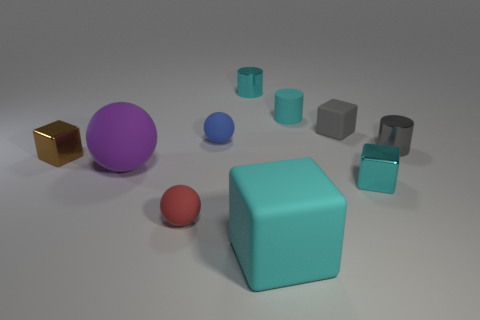Subtract all rubber cylinders. How many cylinders are left? 2 Subtract all red cubes. How many cyan cylinders are left? 2 Subtract 2 cubes. How many cubes are left? 2 Subtract all cubes. How many objects are left? 6 Subtract all brown blocks. How many blocks are left? 3 Add 6 cylinders. How many cylinders are left? 9 Add 4 large gray cubes. How many large gray cubes exist? 4 Subtract 0 red cylinders. How many objects are left? 10 Subtract all yellow cylinders. Subtract all red balls. How many cylinders are left? 3 Subtract all cyan matte cubes. Subtract all purple metal blocks. How many objects are left? 9 